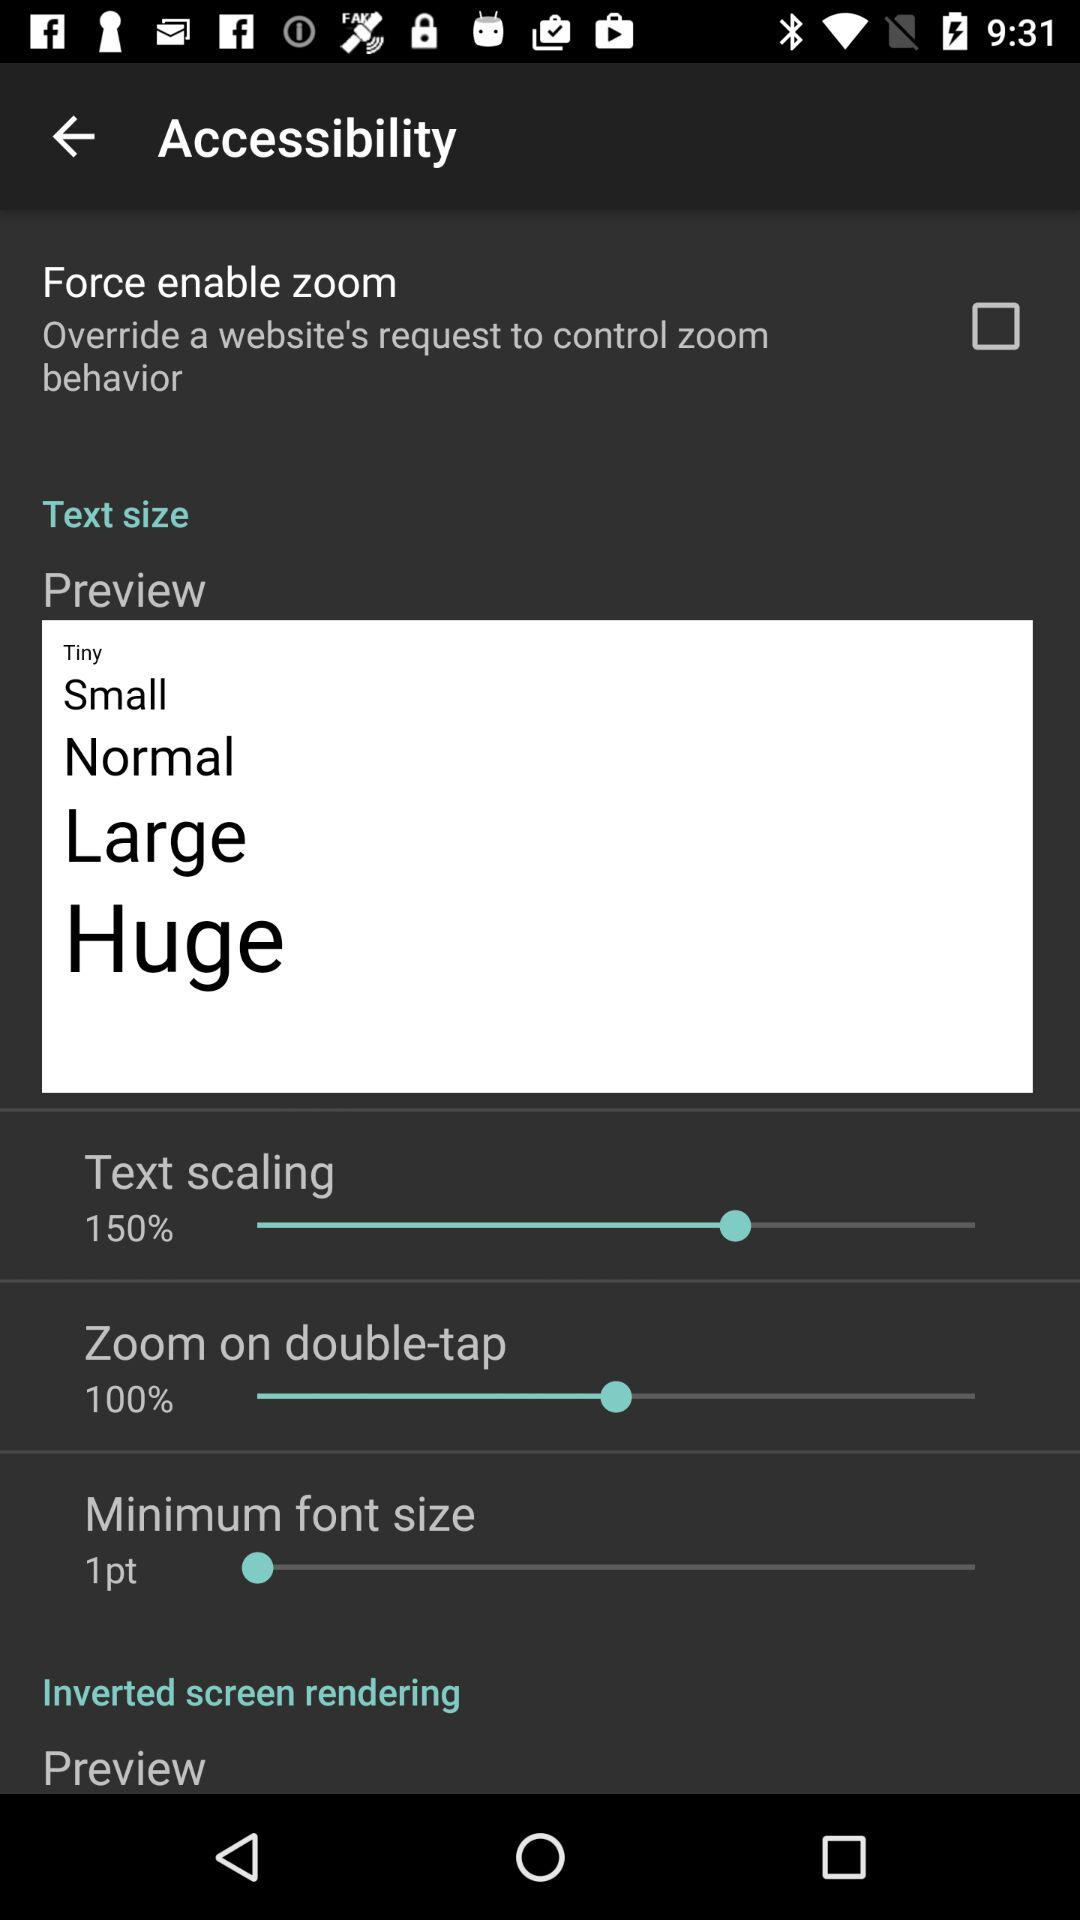What is the status of "Force enable zoom"? The status is "off". 